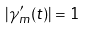Convert formula to latex. <formula><loc_0><loc_0><loc_500><loc_500>| \gamma _ { m } ^ { \prime } ( t ) | = 1</formula> 